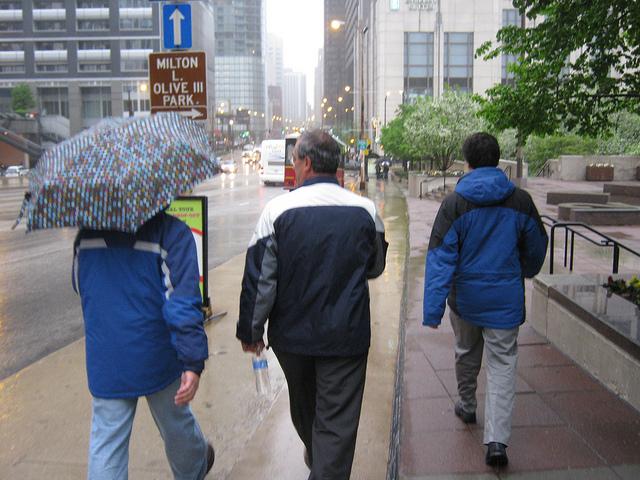Is one of these people receiving assistance?
Be succinct. No. What is the man wearing?
Write a very short answer. Jacket. What color is the arrow?
Keep it brief. White. How many people are seen?
Quick response, please. 3. Is it sunny?
Short answer required. No. How many people are wearing red?
Answer briefly. 0. How many cones are there?
Concise answer only. 0. 